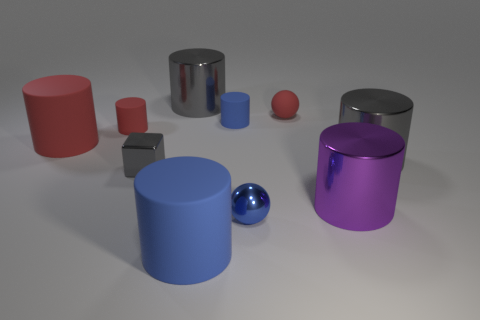Subtract all blue cylinders. How many were subtracted if there are1blue cylinders left? 1 Subtract 1 cylinders. How many cylinders are left? 6 Subtract all purple cylinders. How many cylinders are left? 6 Subtract all tiny red rubber cylinders. How many cylinders are left? 6 Subtract all red cylinders. Subtract all blue spheres. How many cylinders are left? 5 Subtract all balls. How many objects are left? 8 Subtract 1 red spheres. How many objects are left? 9 Subtract all large purple shiny objects. Subtract all tiny blue cylinders. How many objects are left? 8 Add 2 metal spheres. How many metal spheres are left? 3 Add 8 large gray shiny cylinders. How many large gray shiny cylinders exist? 10 